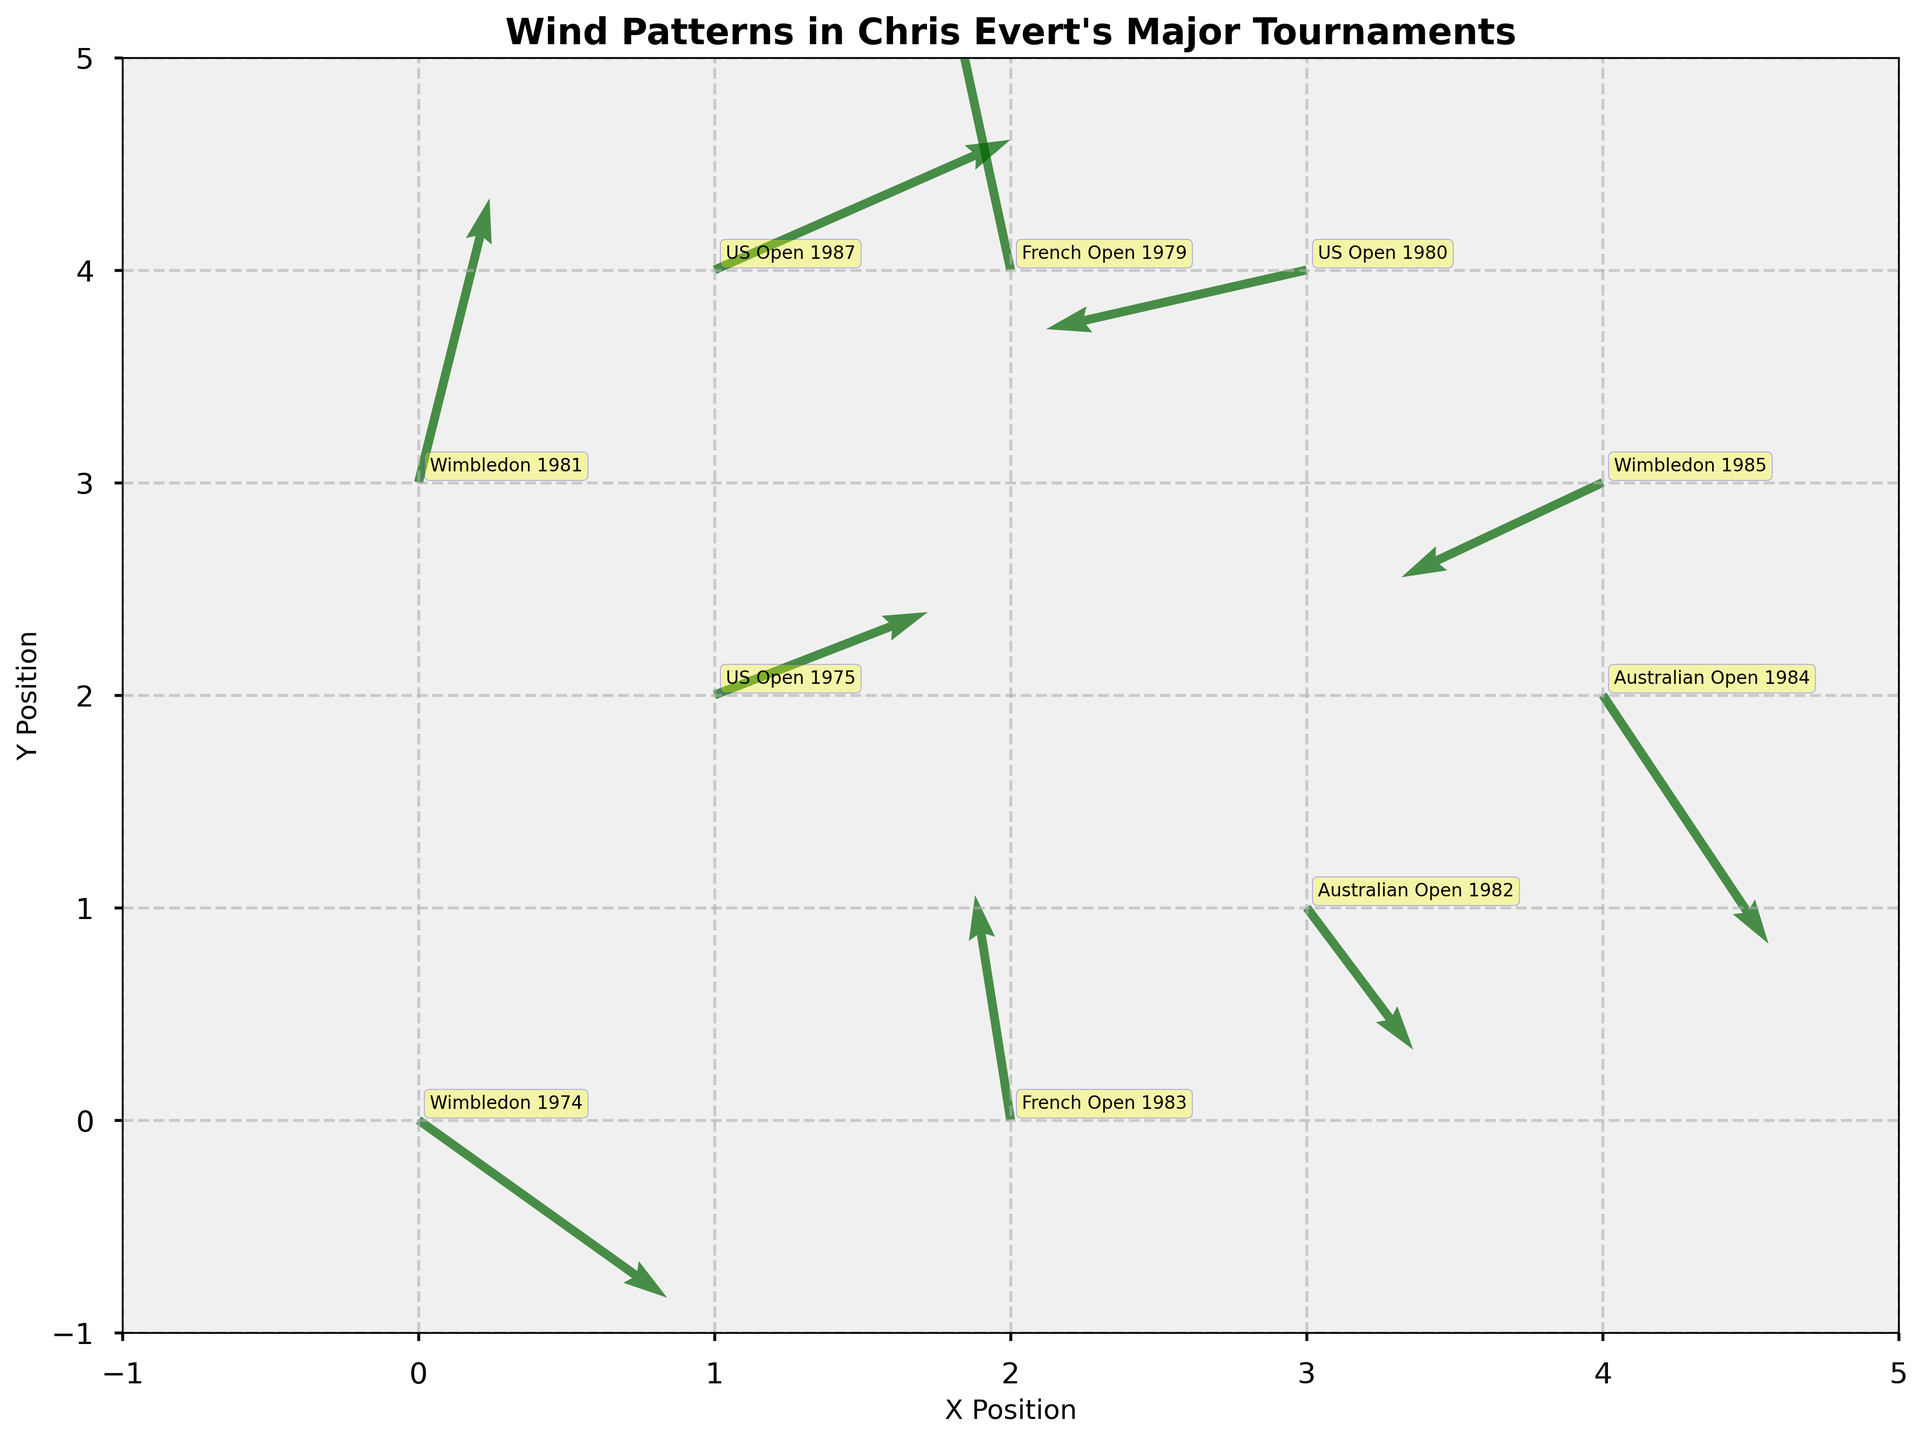How many data points are plotted in the figure? Count the number of arrows, which are 10 in total.
Answer: 10 What is the title of the figure? Look at the top of the figure to read the title.
Answer: "Wind Patterns in Chris Evert's Major Tournaments" Which tournament has the highest x position? Check the x positions and find the maximum value, which is 4. The tournaments at x=4 are Wimbledon 1985 and Australian Open 1984.
Answer: Wimbledon 1985, Australian Open 1984 What is the wind direction for the 1974 Wimbledon tournament? Check the quiver arrow at (0,0); the vector (2.1, -1.5) indicates the wind direction is to the right and slightly downward.
Answer: To the right and slightly downward Which tournament has the strongest wind intensity? Calculate the magnitude of each vector using the formula √(u²+v²). The strongest intensity corresponds to the highest magnitude.
Answer: US Open 1987 What are the x and y positions for the French Open 1979? Locate the corresponding x and y coordinates in the plot or data table, which are (2, 4).
Answer: (2, 4) What is the average wind u-component across all tournaments? Sum the u values (2.1 + 1.8 - 0.5 + 0.9 - 1.7 + 2.5 - 0.3 + 1.4 + 0.6 - 2.2) and divide by the number of data points, i.e., 10.
Answer: 0.46 Which tournament has the most vertical wind component? Compare the absolute values of the v components of each arrow. The highest is 2.4 for Wimbledon 1981.
Answer: Wimbledon 1981 Is the wind direction mostly positive or negative for the y component? Sum all v values (-1.5 + 0.7 + 2.3 - 1.2 - 0.8 + 1.1 + 1.9 - 2.1 + 2.4 - 0.5) to see if positive or negative, resulting in 2.3, which is positive overall.
Answer: Positive 